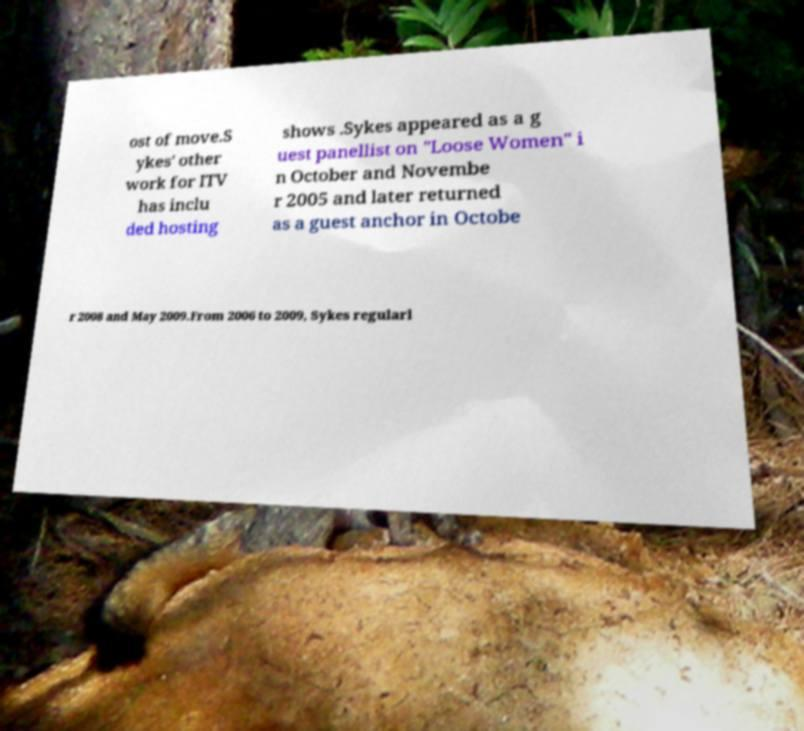Can you read and provide the text displayed in the image?This photo seems to have some interesting text. Can you extract and type it out for me? ost of move.S ykes' other work for ITV has inclu ded hosting shows .Sykes appeared as a g uest panellist on "Loose Women" i n October and Novembe r 2005 and later returned as a guest anchor in Octobe r 2008 and May 2009.From 2006 to 2009, Sykes regularl 